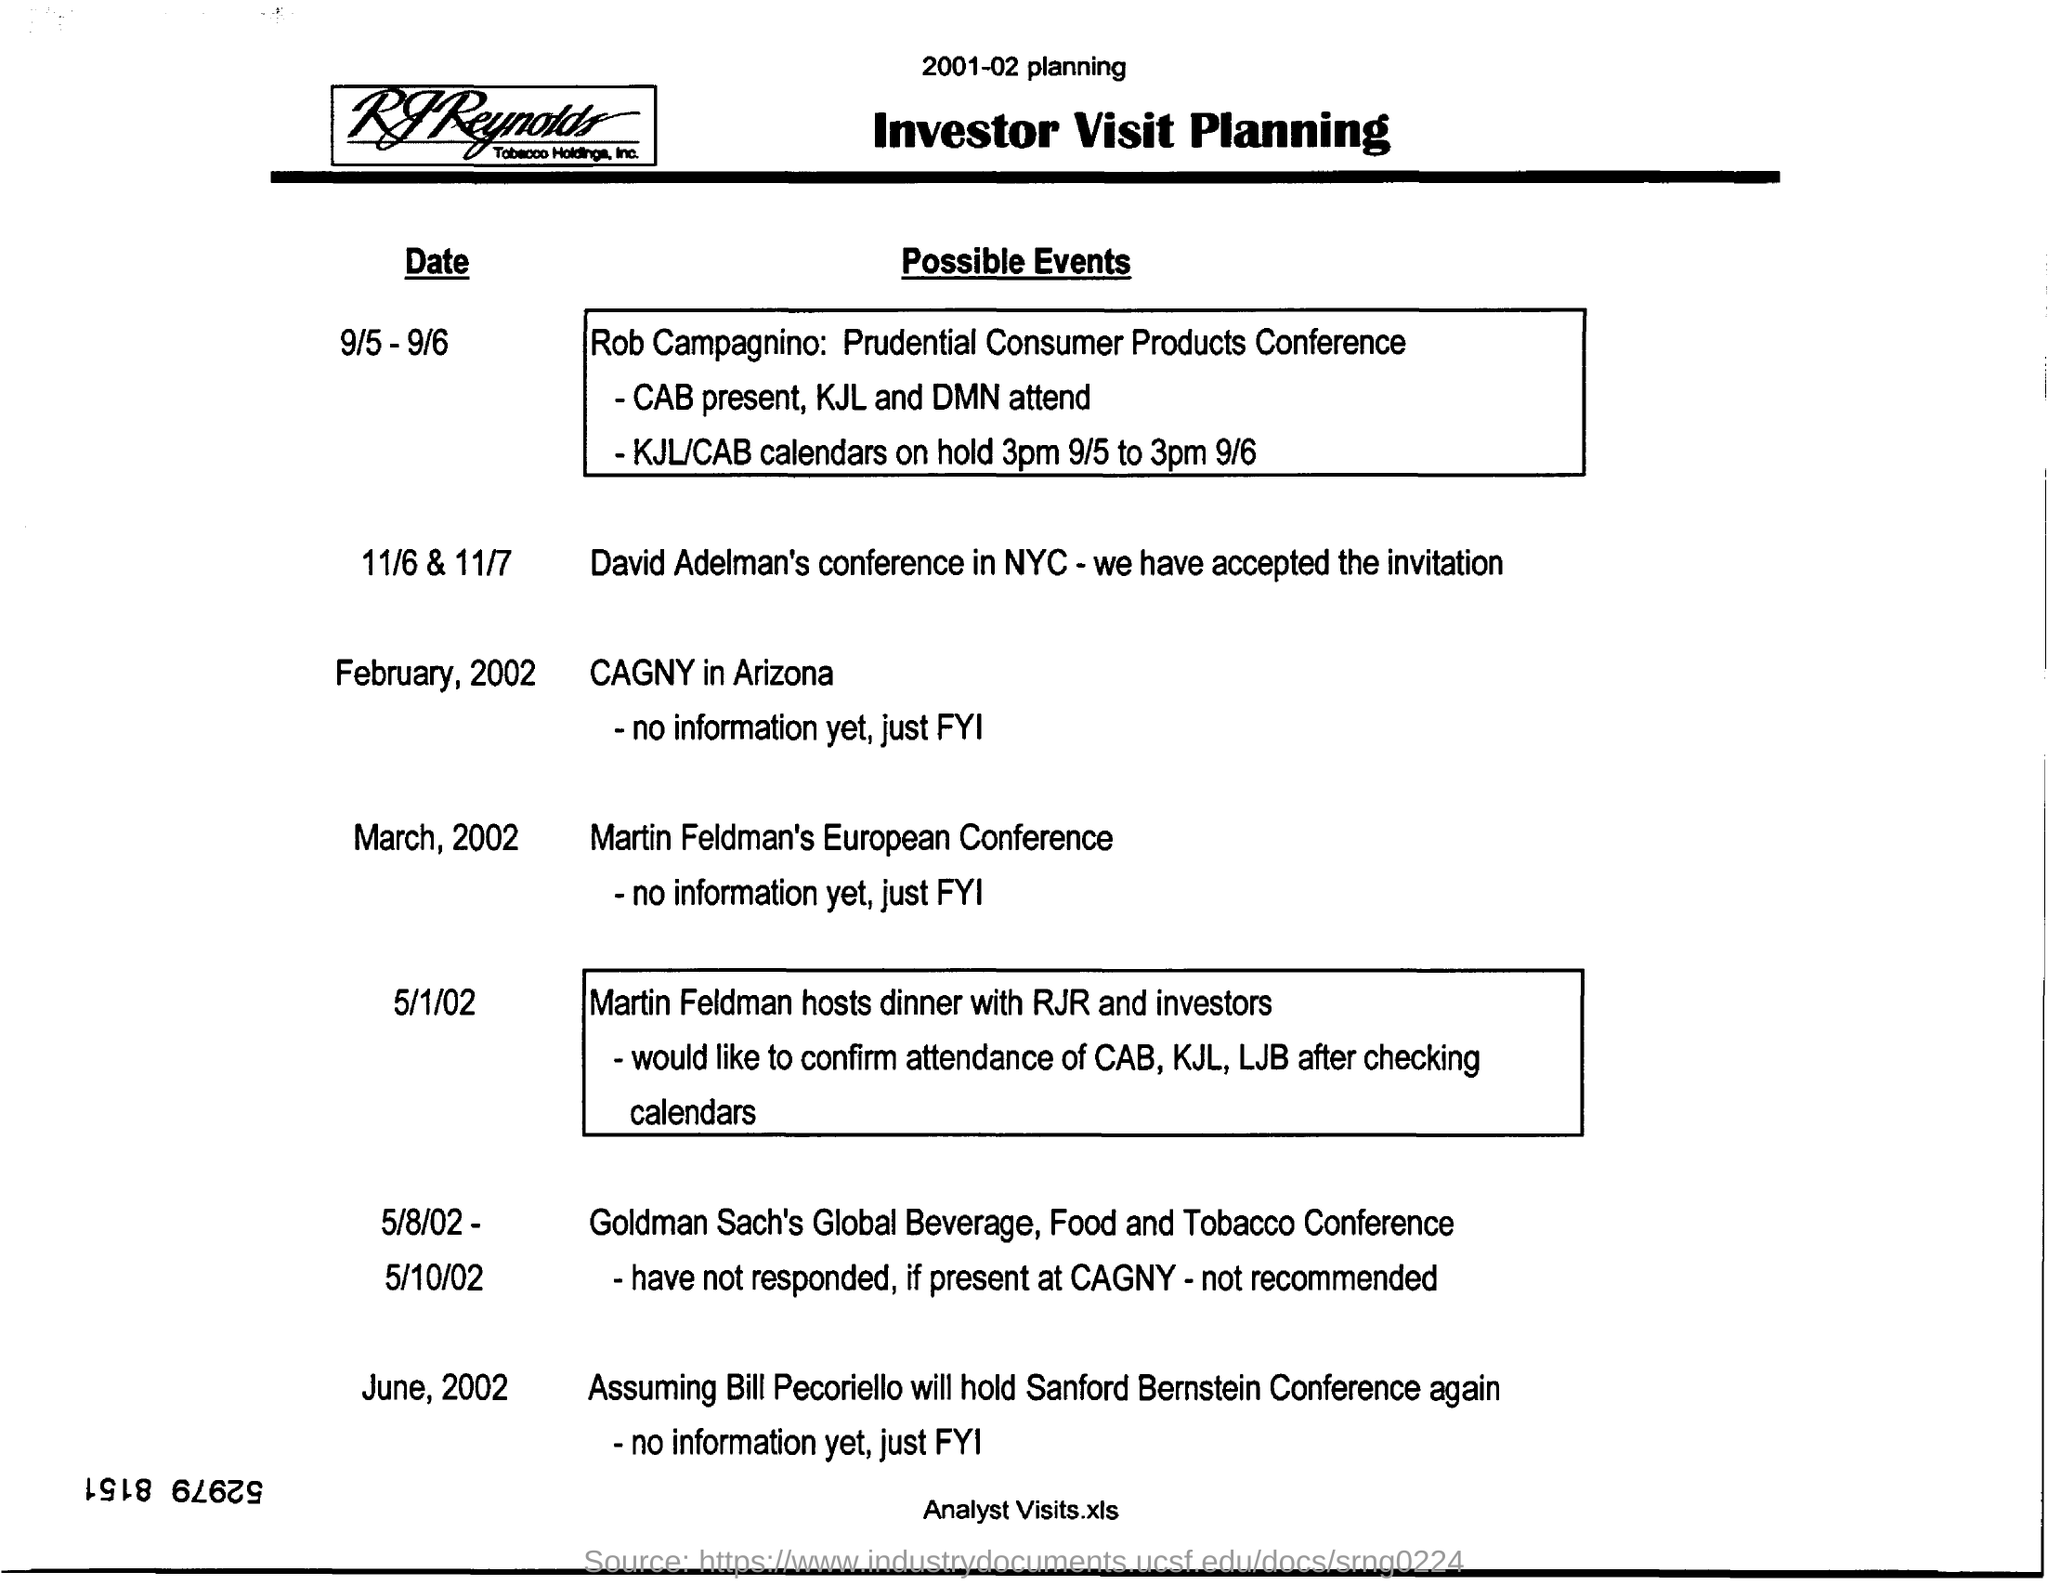David Adelman's conference in NYC was held on ?
Ensure brevity in your answer.  11/6 & 11/7. What was the conference held on march, 2002?
Your answer should be very brief. Martin Feldman's european conference. Name the Conference held on 5/8/02.
Your answer should be compact. Goldman Sach's Global Beverage, Food and Tobacco Conference. 